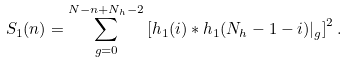Convert formula to latex. <formula><loc_0><loc_0><loc_500><loc_500>S _ { 1 } ( n ) = \sum _ { g = 0 } ^ { N - n + N _ { h } - 2 } \left [ h _ { 1 } ( i ) * h _ { 1 } ( N _ { h } - 1 - i ) | _ { g } \right ] ^ { 2 } .</formula> 